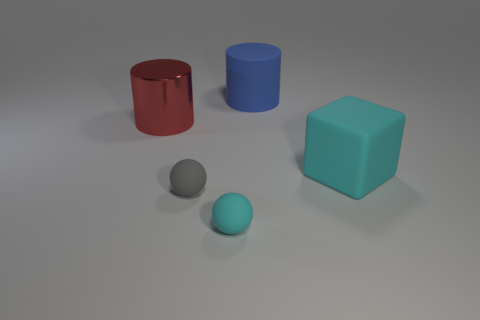What size is the thing that is the same color as the rubber cube?
Offer a terse response. Small. How many other objects are the same size as the metal object?
Keep it short and to the point. 2. What is the color of the ball that is left of the tiny cyan object?
Your answer should be compact. Gray. Are the cylinder behind the red metal cylinder and the small cyan object made of the same material?
Keep it short and to the point. Yes. What number of big rubber things are both behind the metal object and in front of the large blue cylinder?
Offer a very short reply. 0. What color is the small ball right of the small sphere that is on the left side of the cyan matte object to the left of the big cyan matte thing?
Give a very brief answer. Cyan. What number of other things are there of the same shape as the large cyan rubber object?
Your answer should be compact. 0. There is a cylinder that is behind the red shiny cylinder; is there a large metallic thing behind it?
Make the answer very short. No. What number of matte objects are either small cyan things or cyan things?
Provide a short and direct response. 2. There is a object that is left of the large blue cylinder and behind the gray sphere; what is its material?
Your answer should be compact. Metal. 